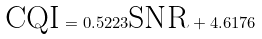<formula> <loc_0><loc_0><loc_500><loc_500>\text {CQI} = 0 . 5 2 2 3 \text {SNR} + 4 . 6 1 7 6</formula> 